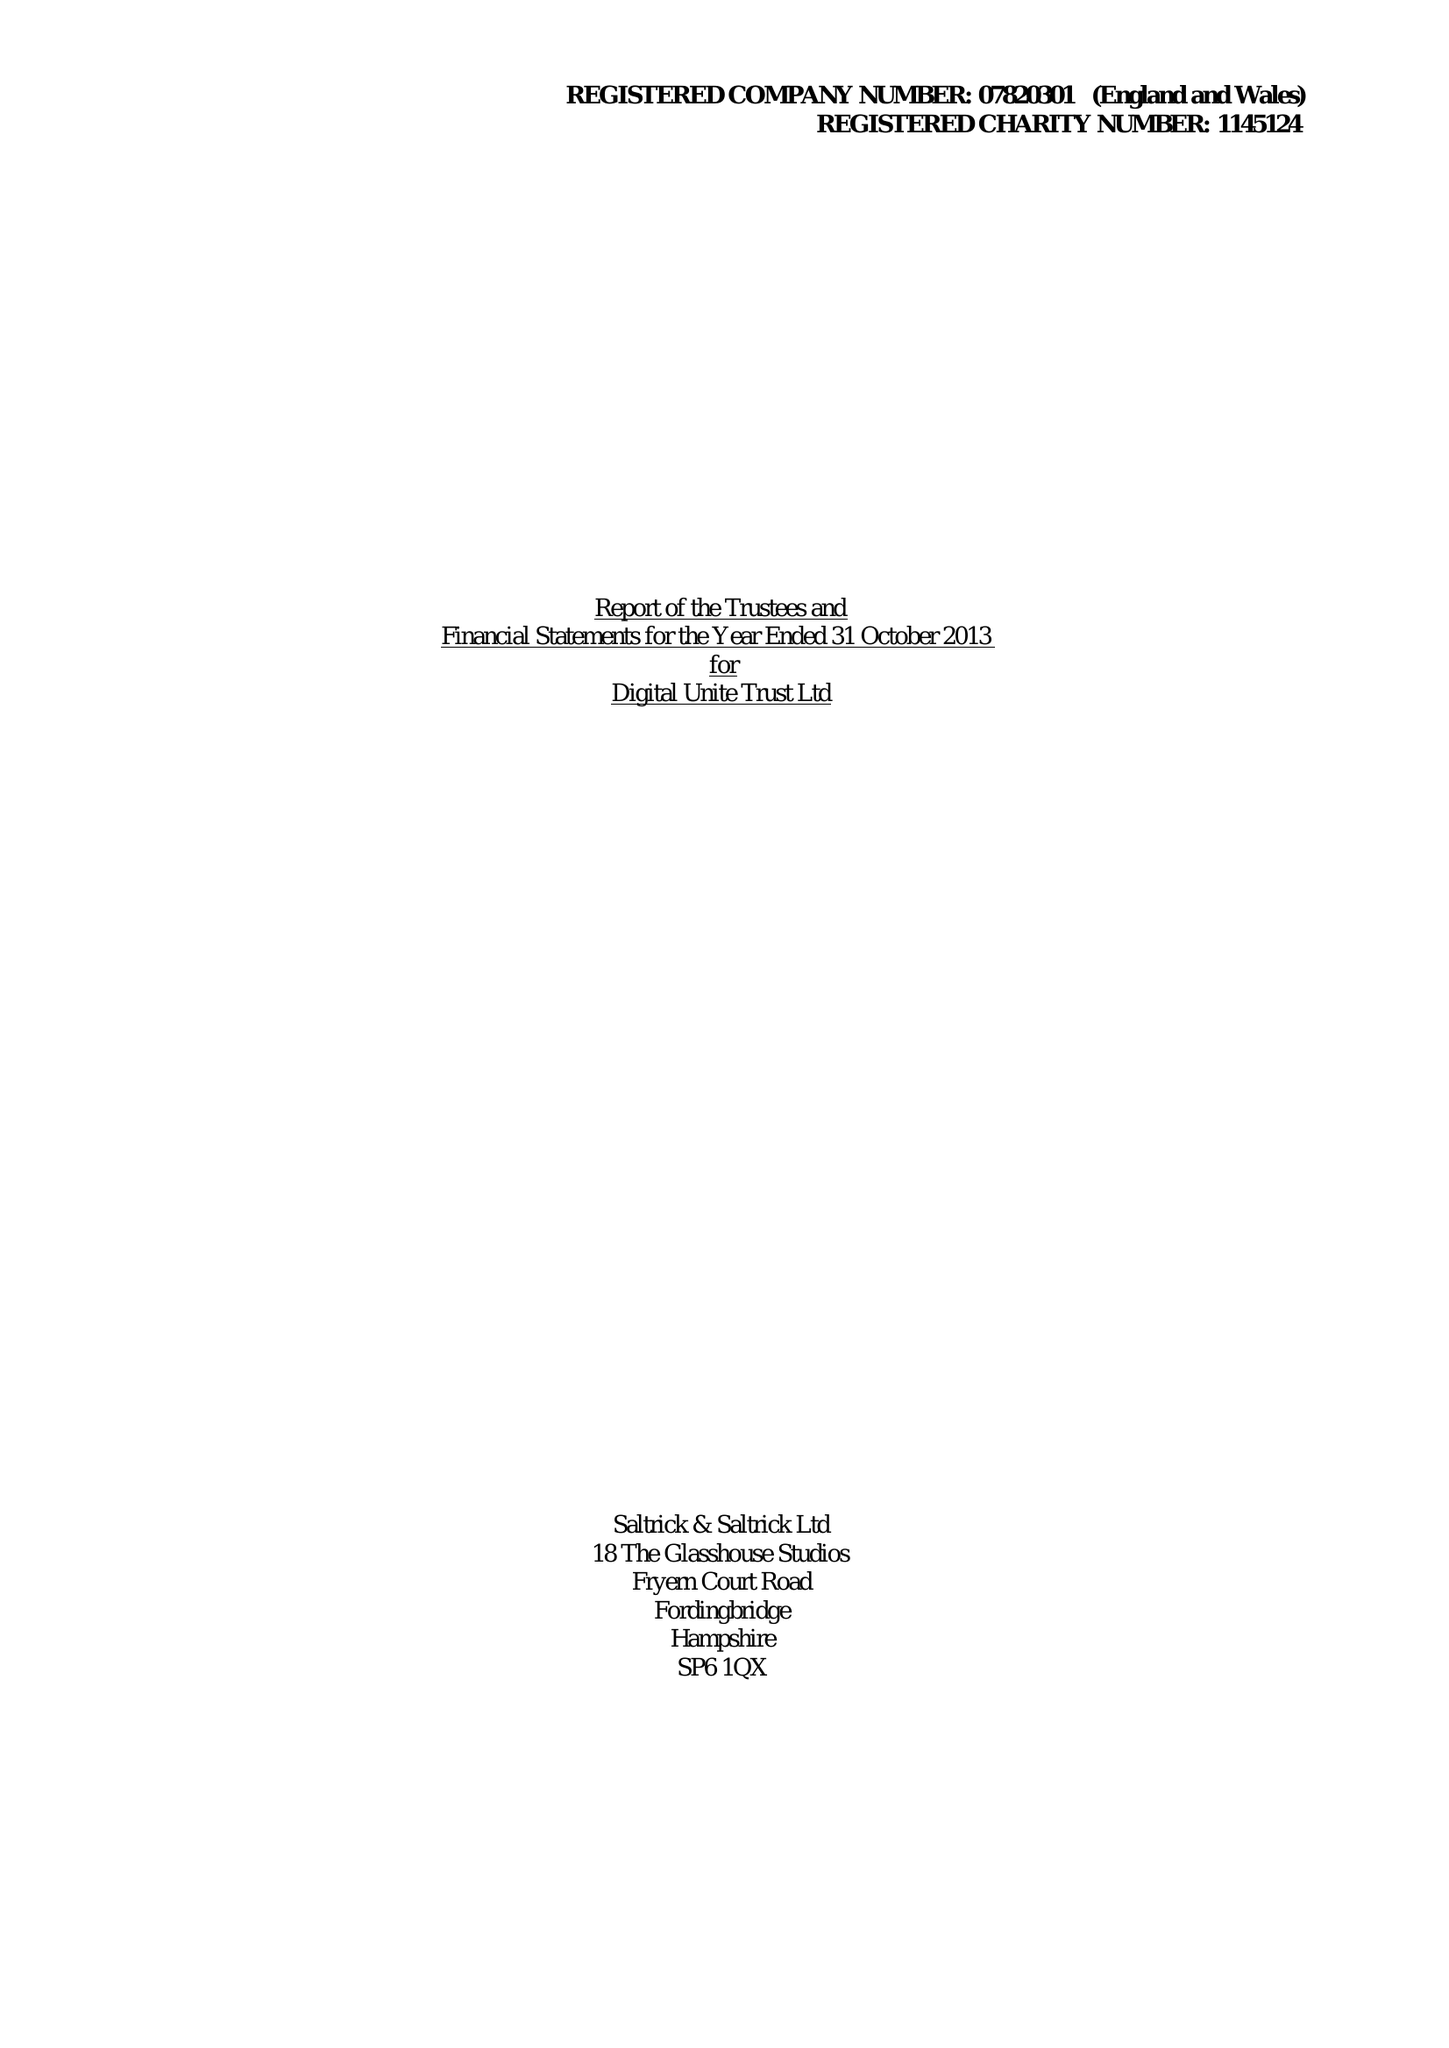What is the value for the address__postcode?
Answer the question using a single word or phrase. PO17 6JB 